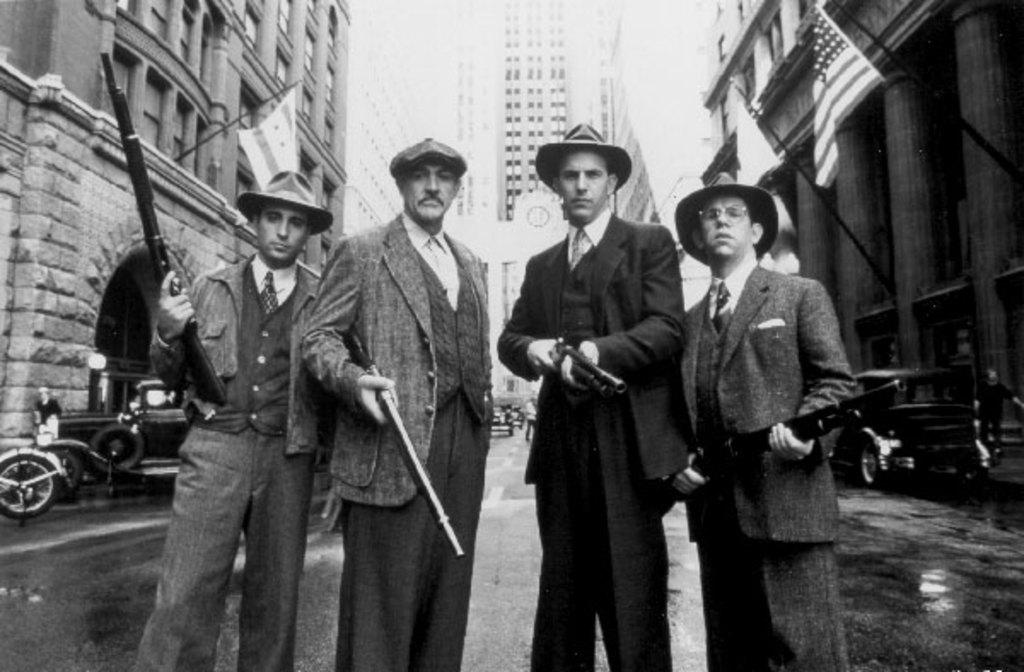How many men are in the image? There are four men in the image. What are the men doing in the image? The men are standing and holding guns. What can be seen on both sides of the image? There are buildings on both the right and left sides of the image. What else is present in the image besides the men and buildings? There are flags and cars in the image. What is the color scheme of the image? The image is black and white. Can you describe the texture of the lake in the image? There is no lake present in the image; it features four men holding guns, buildings, flags, and cars in a black and white setting. What type of market can be seen in the image? There is no market present in the image. 